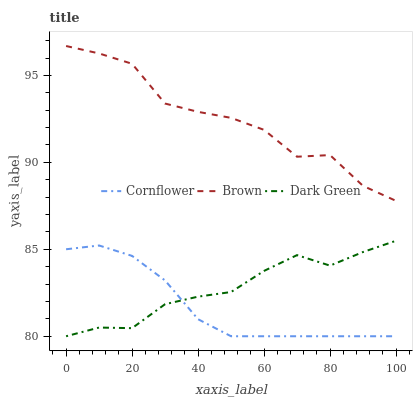Does Cornflower have the minimum area under the curve?
Answer yes or no. Yes. Does Brown have the maximum area under the curve?
Answer yes or no. Yes. Does Dark Green have the minimum area under the curve?
Answer yes or no. No. Does Dark Green have the maximum area under the curve?
Answer yes or no. No. Is Cornflower the smoothest?
Answer yes or no. Yes. Is Brown the roughest?
Answer yes or no. Yes. Is Dark Green the smoothest?
Answer yes or no. No. Is Dark Green the roughest?
Answer yes or no. No. Does Brown have the lowest value?
Answer yes or no. No. Does Brown have the highest value?
Answer yes or no. Yes. Does Dark Green have the highest value?
Answer yes or no. No. Is Dark Green less than Brown?
Answer yes or no. Yes. Is Brown greater than Cornflower?
Answer yes or no. Yes. Does Dark Green intersect Brown?
Answer yes or no. No. 